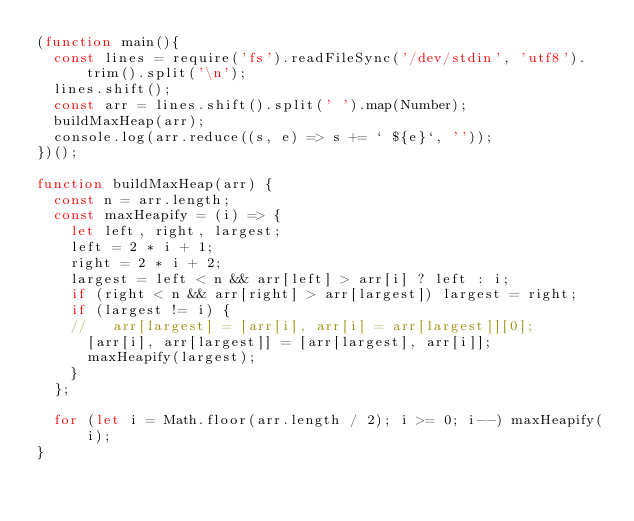Convert code to text. <code><loc_0><loc_0><loc_500><loc_500><_JavaScript_>(function main(){
  const lines = require('fs').readFileSync('/dev/stdin', 'utf8').trim().split('\n');
  lines.shift();
  const arr = lines.shift().split(' ').map(Number);
  buildMaxHeap(arr);
  console.log(arr.reduce((s, e) => s += ` ${e}`, ''));
})();

function buildMaxHeap(arr) {
  const n = arr.length;
  const maxHeapify = (i) => {
    let left, right, largest;
    left = 2 * i + 1;
    right = 2 * i + 2;
    largest = left < n && arr[left] > arr[i] ? left : i;
    if (right < n && arr[right] > arr[largest]) largest = right;
    if (largest != i) {
    //   arr[largest] = [arr[i], arr[i] = arr[largest]][0];
      [arr[i], arr[largest]] = [arr[largest], arr[i]];
      maxHeapify(largest);
    }
  };

  for (let i = Math.floor(arr.length / 2); i >= 0; i--) maxHeapify(i);
}

</code> 